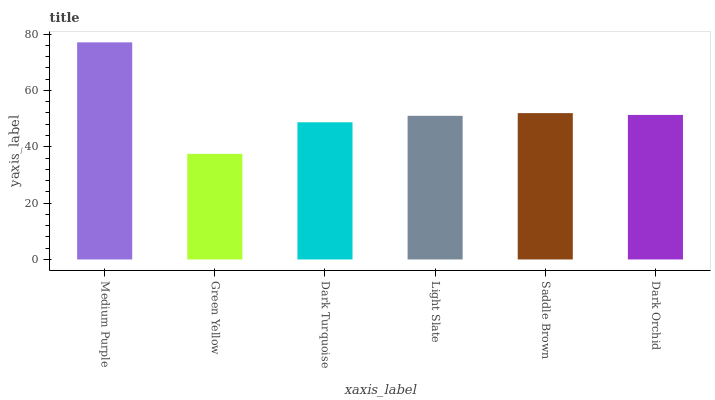Is Green Yellow the minimum?
Answer yes or no. Yes. Is Medium Purple the maximum?
Answer yes or no. Yes. Is Dark Turquoise the minimum?
Answer yes or no. No. Is Dark Turquoise the maximum?
Answer yes or no. No. Is Dark Turquoise greater than Green Yellow?
Answer yes or no. Yes. Is Green Yellow less than Dark Turquoise?
Answer yes or no. Yes. Is Green Yellow greater than Dark Turquoise?
Answer yes or no. No. Is Dark Turquoise less than Green Yellow?
Answer yes or no. No. Is Dark Orchid the high median?
Answer yes or no. Yes. Is Light Slate the low median?
Answer yes or no. Yes. Is Dark Turquoise the high median?
Answer yes or no. No. Is Dark Orchid the low median?
Answer yes or no. No. 